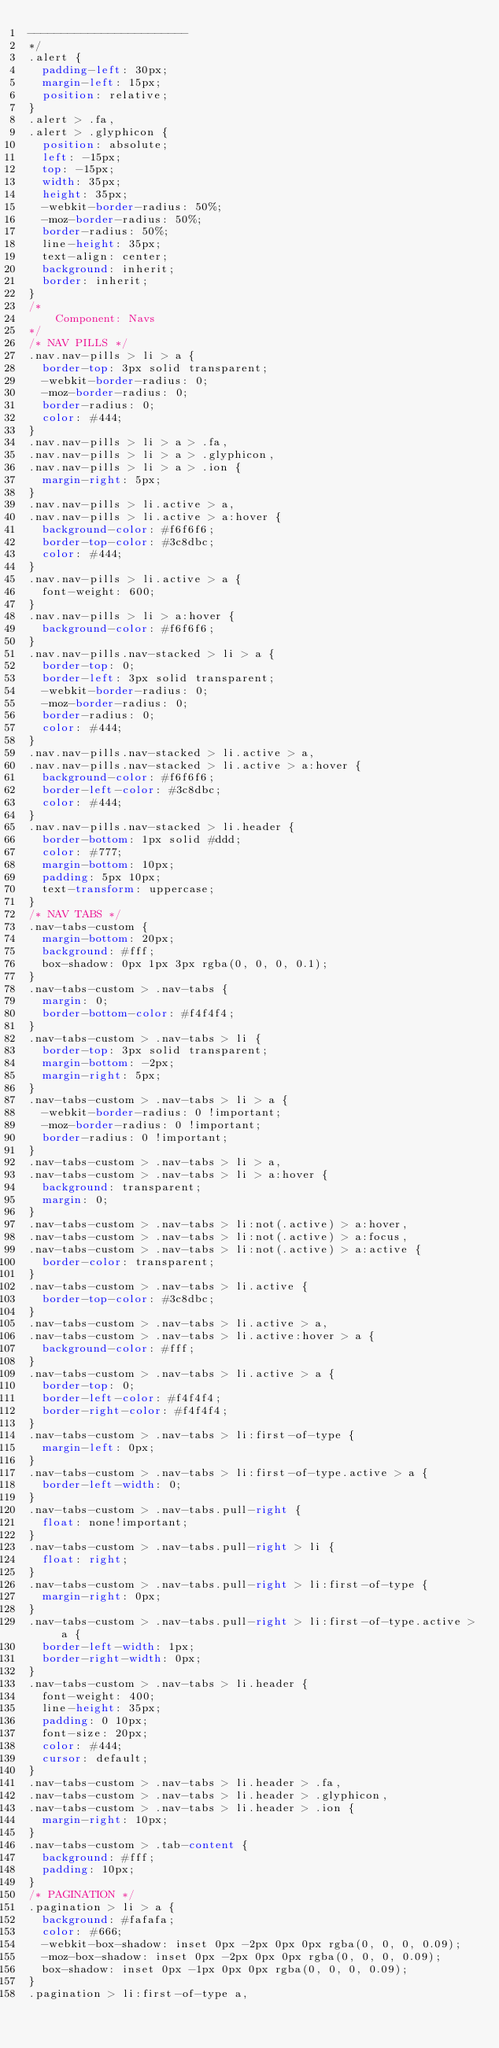Convert code to text. <code><loc_0><loc_0><loc_500><loc_500><_CSS_>------------------------
*/
.alert {
  padding-left: 30px;
  margin-left: 15px;
  position: relative;
}
.alert > .fa,
.alert > .glyphicon {
  position: absolute;
  left: -15px;
  top: -15px;
  width: 35px;
  height: 35px;
  -webkit-border-radius: 50%;
  -moz-border-radius: 50%;
  border-radius: 50%;
  line-height: 35px;
  text-align: center;
  background: inherit;
  border: inherit;
}
/*
    Component: Navs
*/
/* NAV PILLS */
.nav.nav-pills > li > a {
  border-top: 3px solid transparent;
  -webkit-border-radius: 0;
  -moz-border-radius: 0;
  border-radius: 0;
  color: #444;
}
.nav.nav-pills > li > a > .fa,
.nav.nav-pills > li > a > .glyphicon,
.nav.nav-pills > li > a > .ion {
  margin-right: 5px;
}
.nav.nav-pills > li.active > a,
.nav.nav-pills > li.active > a:hover {
  background-color: #f6f6f6;
  border-top-color: #3c8dbc;
  color: #444;
}
.nav.nav-pills > li.active > a {
  font-weight: 600;
}
.nav.nav-pills > li > a:hover {
  background-color: #f6f6f6;
}
.nav.nav-pills.nav-stacked > li > a {
  border-top: 0;
  border-left: 3px solid transparent;
  -webkit-border-radius: 0;
  -moz-border-radius: 0;
  border-radius: 0;
  color: #444;
}
.nav.nav-pills.nav-stacked > li.active > a,
.nav.nav-pills.nav-stacked > li.active > a:hover {
  background-color: #f6f6f6;
  border-left-color: #3c8dbc;
  color: #444;
}
.nav.nav-pills.nav-stacked > li.header {
  border-bottom: 1px solid #ddd;
  color: #777;
  margin-bottom: 10px;
  padding: 5px 10px;
  text-transform: uppercase;
}
/* NAV TABS */
.nav-tabs-custom {
  margin-bottom: 20px;
  background: #fff;
  box-shadow: 0px 1px 3px rgba(0, 0, 0, 0.1);
}
.nav-tabs-custom > .nav-tabs {
  margin: 0;
  border-bottom-color: #f4f4f4;
}
.nav-tabs-custom > .nav-tabs > li {
  border-top: 3px solid transparent;
  margin-bottom: -2px;
  margin-right: 5px;
}
.nav-tabs-custom > .nav-tabs > li > a {
  -webkit-border-radius: 0 !important;
  -moz-border-radius: 0 !important;
  border-radius: 0 !important;
}
.nav-tabs-custom > .nav-tabs > li > a,
.nav-tabs-custom > .nav-tabs > li > a:hover {
  background: transparent;
  margin: 0;
}
.nav-tabs-custom > .nav-tabs > li:not(.active) > a:hover,
.nav-tabs-custom > .nav-tabs > li:not(.active) > a:focus,
.nav-tabs-custom > .nav-tabs > li:not(.active) > a:active {
  border-color: transparent;
}
.nav-tabs-custom > .nav-tabs > li.active {
  border-top-color: #3c8dbc;
}
.nav-tabs-custom > .nav-tabs > li.active > a,
.nav-tabs-custom > .nav-tabs > li.active:hover > a {
  background-color: #fff;
}
.nav-tabs-custom > .nav-tabs > li.active > a {
  border-top: 0;
  border-left-color: #f4f4f4;
  border-right-color: #f4f4f4;
}
.nav-tabs-custom > .nav-tabs > li:first-of-type {
  margin-left: 0px;
}
.nav-tabs-custom > .nav-tabs > li:first-of-type.active > a {
  border-left-width: 0;
}
.nav-tabs-custom > .nav-tabs.pull-right {
  float: none!important;
}
.nav-tabs-custom > .nav-tabs.pull-right > li {
  float: right;
}
.nav-tabs-custom > .nav-tabs.pull-right > li:first-of-type {
  margin-right: 0px;
}
.nav-tabs-custom > .nav-tabs.pull-right > li:first-of-type.active > a {
  border-left-width: 1px;
  border-right-width: 0px;
}
.nav-tabs-custom > .nav-tabs > li.header {
  font-weight: 400;
  line-height: 35px;
  padding: 0 10px;
  font-size: 20px;
  color: #444;
  cursor: default;
}
.nav-tabs-custom > .nav-tabs > li.header > .fa,
.nav-tabs-custom > .nav-tabs > li.header > .glyphicon,
.nav-tabs-custom > .nav-tabs > li.header > .ion {
  margin-right: 10px;
}
.nav-tabs-custom > .tab-content {
  background: #fff;
  padding: 10px;
}
/* PAGINATION */
.pagination > li > a {
  background: #fafafa;
  color: #666;
  -webkit-box-shadow: inset 0px -2px 0px 0px rgba(0, 0, 0, 0.09);
  -moz-box-shadow: inset 0px -2px 0px 0px rgba(0, 0, 0, 0.09);
  box-shadow: inset 0px -1px 0px 0px rgba(0, 0, 0, 0.09);
}
.pagination > li:first-of-type a,</code> 